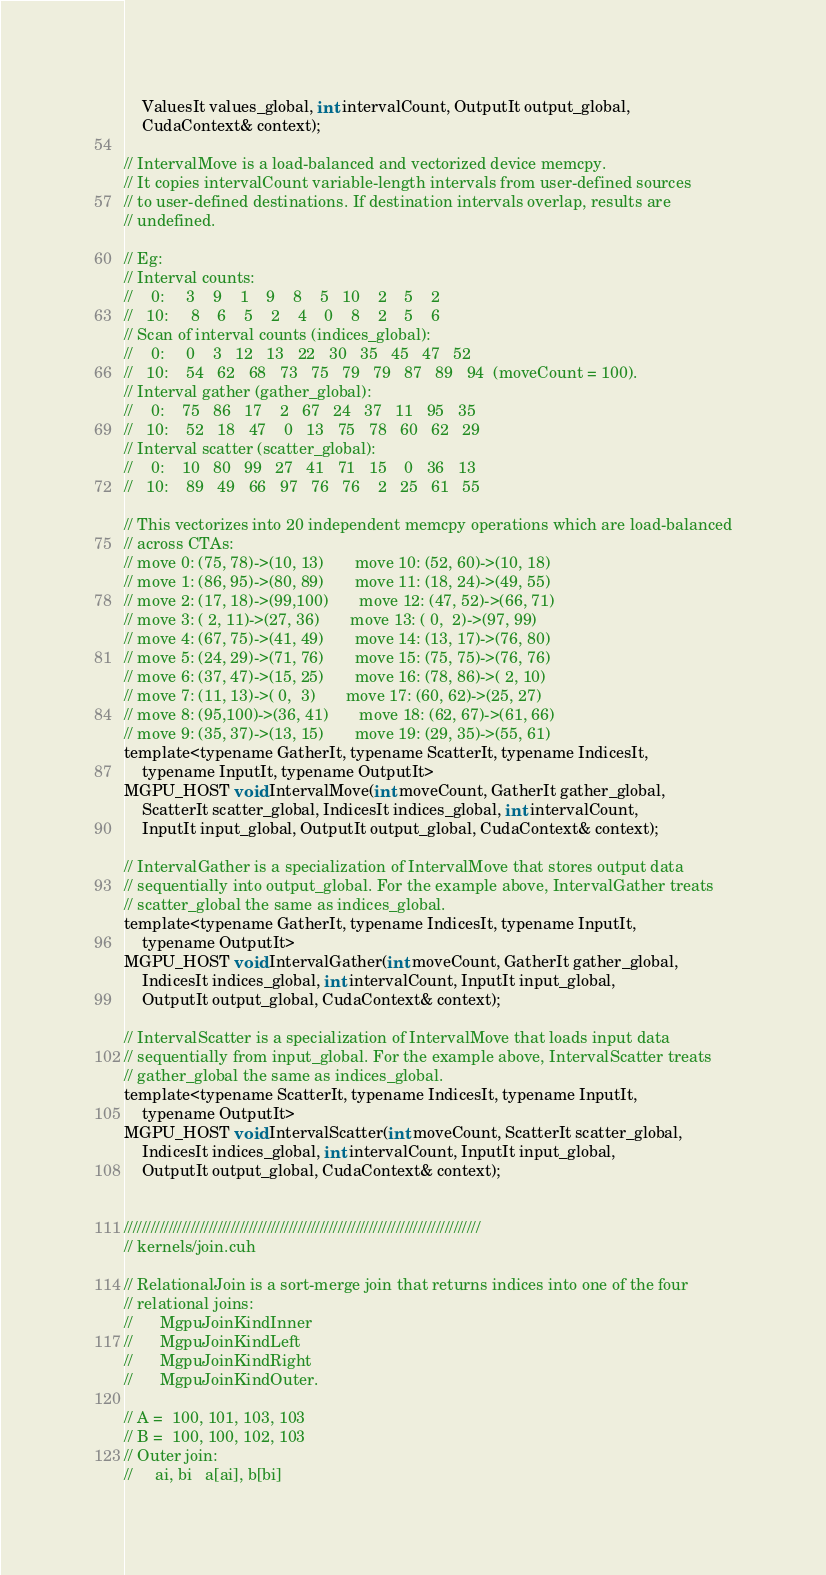Convert code to text. <code><loc_0><loc_0><loc_500><loc_500><_Cuda_>	ValuesIt values_global, int intervalCount, OutputIt output_global,
	CudaContext& context);

// IntervalMove is a load-balanced and vectorized device memcpy.
// It copies intervalCount variable-length intervals from user-defined sources
// to user-defined destinations. If destination intervals overlap, results are
// undefined.

// Eg:
// Interval counts:
//    0:     3    9    1    9    8    5   10    2    5    2
//   10:     8    6    5    2    4    0    8    2    5    6
// Scan of interval counts (indices_global):
//    0:     0    3   12   13   22   30   35   45   47   52
//   10:    54   62   68   73   75   79   79   87   89   94  (moveCount = 100).
// Interval gather (gather_global):
//    0:    75   86   17    2   67   24   37   11   95   35
//   10:    52   18   47    0   13   75   78   60   62   29
// Interval scatter (scatter_global):
//    0:    10   80   99   27   41   71   15    0   36   13
//   10:    89   49   66   97   76   76    2   25   61   55

// This vectorizes into 20 independent memcpy operations which are load-balanced
// across CTAs:
// move 0: (75, 78)->(10, 13)       move 10: (52, 60)->(10, 18)
// move 1: (86, 95)->(80, 89)       move 11: (18, 24)->(49, 55)
// move 2: (17, 18)->(99,100)       move 12: (47, 52)->(66, 71)
// move 3: ( 2, 11)->(27, 36)       move 13: ( 0,  2)->(97, 99)
// move 4: (67, 75)->(41, 49)       move 14: (13, 17)->(76, 80)
// move 5: (24, 29)->(71, 76)       move 15: (75, 75)->(76, 76)
// move 6: (37, 47)->(15, 25)       move 16: (78, 86)->( 2, 10)
// move 7: (11, 13)->( 0,  3)       move 17: (60, 62)->(25, 27)
// move 8: (95,100)->(36, 41)       move 18: (62, 67)->(61, 66)
// move 9: (35, 37)->(13, 15)       move 19: (29, 35)->(55, 61)
template<typename GatherIt, typename ScatterIt, typename IndicesIt, 
	typename InputIt, typename OutputIt>
MGPU_HOST void IntervalMove(int moveCount, GatherIt gather_global, 
	ScatterIt scatter_global, IndicesIt indices_global, int intervalCount, 
	InputIt input_global, OutputIt output_global, CudaContext& context);

// IntervalGather is a specialization of IntervalMove that stores output data
// sequentially into output_global. For the example above, IntervalGather treats
// scatter_global the same as indices_global.
template<typename GatherIt, typename IndicesIt, typename InputIt,
	typename OutputIt>
MGPU_HOST void IntervalGather(int moveCount, GatherIt gather_global, 
	IndicesIt indices_global, int intervalCount, InputIt input_global,
	OutputIt output_global, CudaContext& context);

// IntervalScatter is a specialization of IntervalMove that loads input data
// sequentially from input_global. For the example above, IntervalScatter treats
// gather_global the same as indices_global.
template<typename ScatterIt, typename IndicesIt, typename InputIt,
	typename OutputIt>
MGPU_HOST void IntervalScatter(int moveCount, ScatterIt scatter_global,
	IndicesIt indices_global, int intervalCount, InputIt input_global,
	OutputIt output_global, CudaContext& context);


////////////////////////////////////////////////////////////////////////////////
// kernels/join.cuh

// RelationalJoin is a sort-merge join that returns indices into one of the four
// relational joins:
//		MgpuJoinKindInner
//		MgpuJoinKindLeft
//		MgpuJoinKindRight
//		MgpuJoinKindOuter.

// A =  100, 101, 103, 103
// B =  100, 100, 102, 103
// Outer join:
//     ai, bi   a[ai], b[bi]</code> 